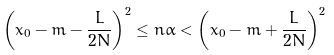<formula> <loc_0><loc_0><loc_500><loc_500>\left ( x _ { 0 } - m - \frac { L } { 2 N } \right ) ^ { 2 } \leq n \alpha < \left ( x _ { 0 } - m + \frac { L } { 2 N } \right ) ^ { 2 }</formula> 